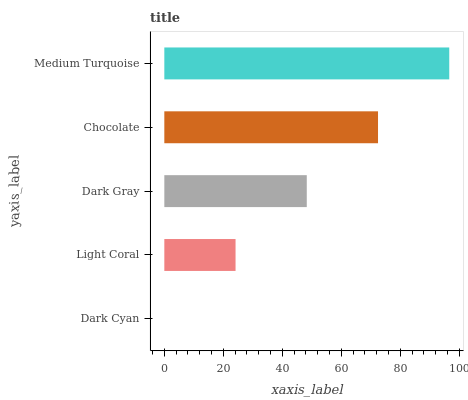Is Dark Cyan the minimum?
Answer yes or no. Yes. Is Medium Turquoise the maximum?
Answer yes or no. Yes. Is Light Coral the minimum?
Answer yes or no. No. Is Light Coral the maximum?
Answer yes or no. No. Is Light Coral greater than Dark Cyan?
Answer yes or no. Yes. Is Dark Cyan less than Light Coral?
Answer yes or no. Yes. Is Dark Cyan greater than Light Coral?
Answer yes or no. No. Is Light Coral less than Dark Cyan?
Answer yes or no. No. Is Dark Gray the high median?
Answer yes or no. Yes. Is Dark Gray the low median?
Answer yes or no. Yes. Is Chocolate the high median?
Answer yes or no. No. Is Medium Turquoise the low median?
Answer yes or no. No. 